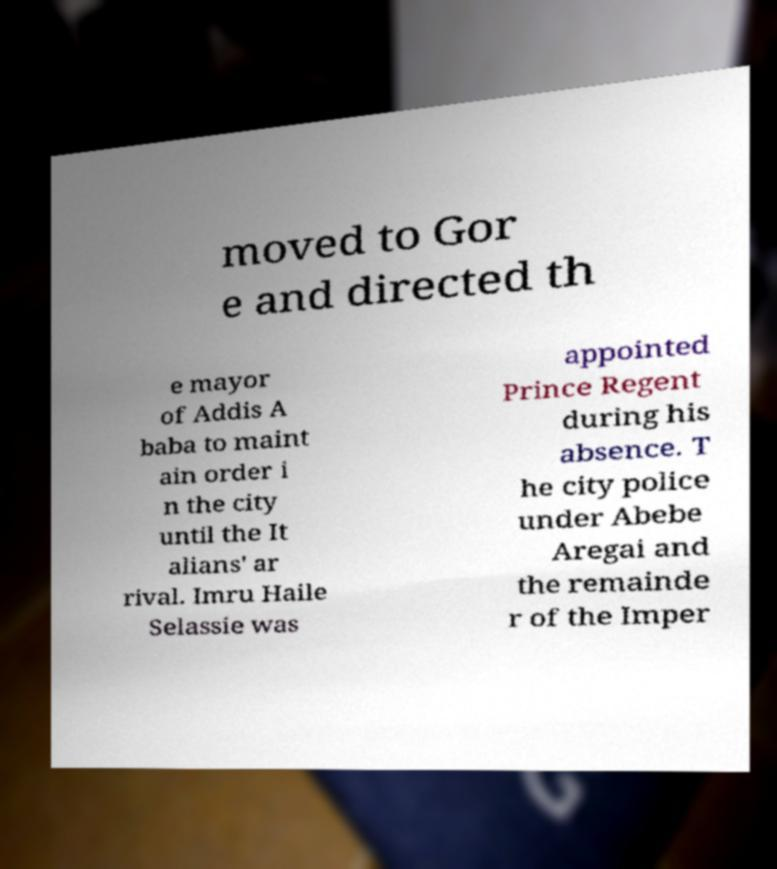There's text embedded in this image that I need extracted. Can you transcribe it verbatim? moved to Gor e and directed th e mayor of Addis A baba to maint ain order i n the city until the It alians' ar rival. Imru Haile Selassie was appointed Prince Regent during his absence. T he city police under Abebe Aregai and the remainde r of the Imper 